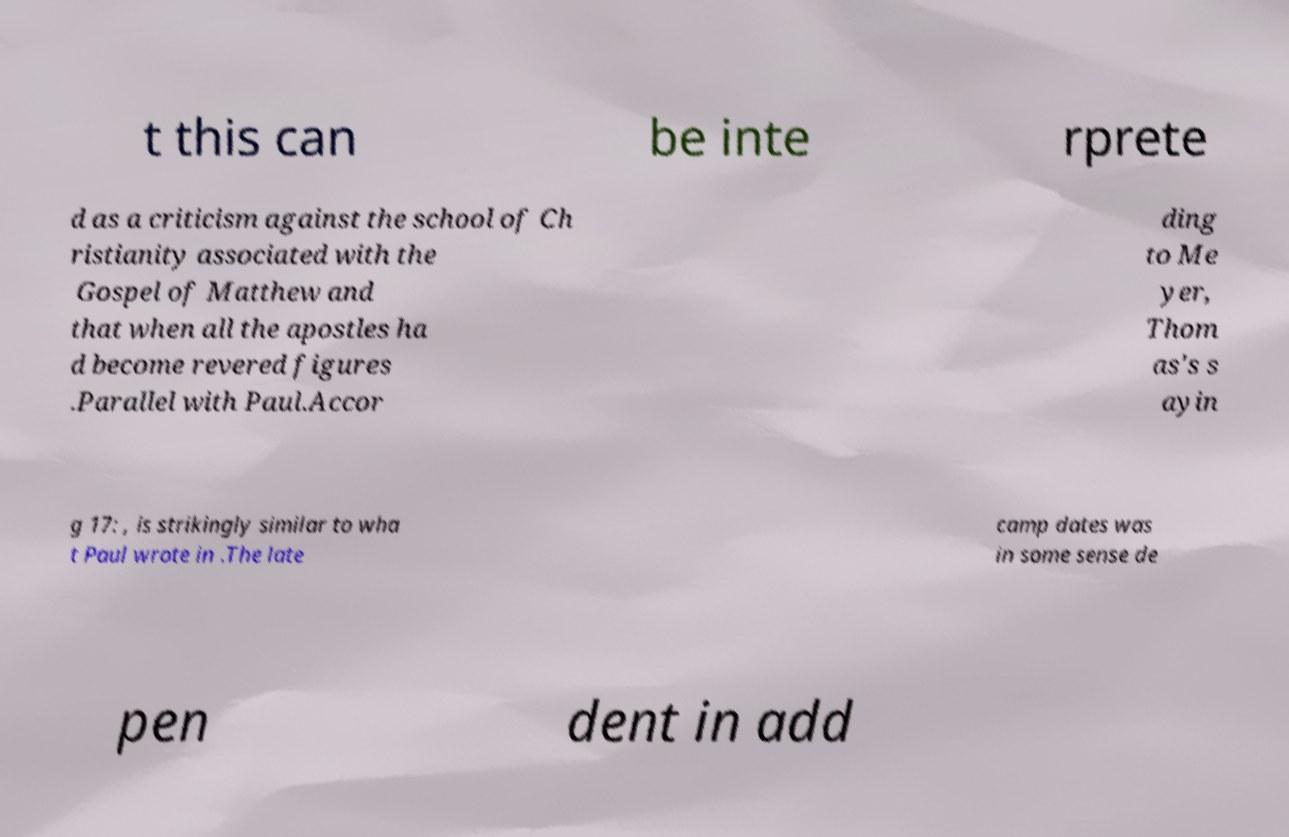For documentation purposes, I need the text within this image transcribed. Could you provide that? t this can be inte rprete d as a criticism against the school of Ch ristianity associated with the Gospel of Matthew and that when all the apostles ha d become revered figures .Parallel with Paul.Accor ding to Me yer, Thom as's s ayin g 17: , is strikingly similar to wha t Paul wrote in .The late camp dates was in some sense de pen dent in add 